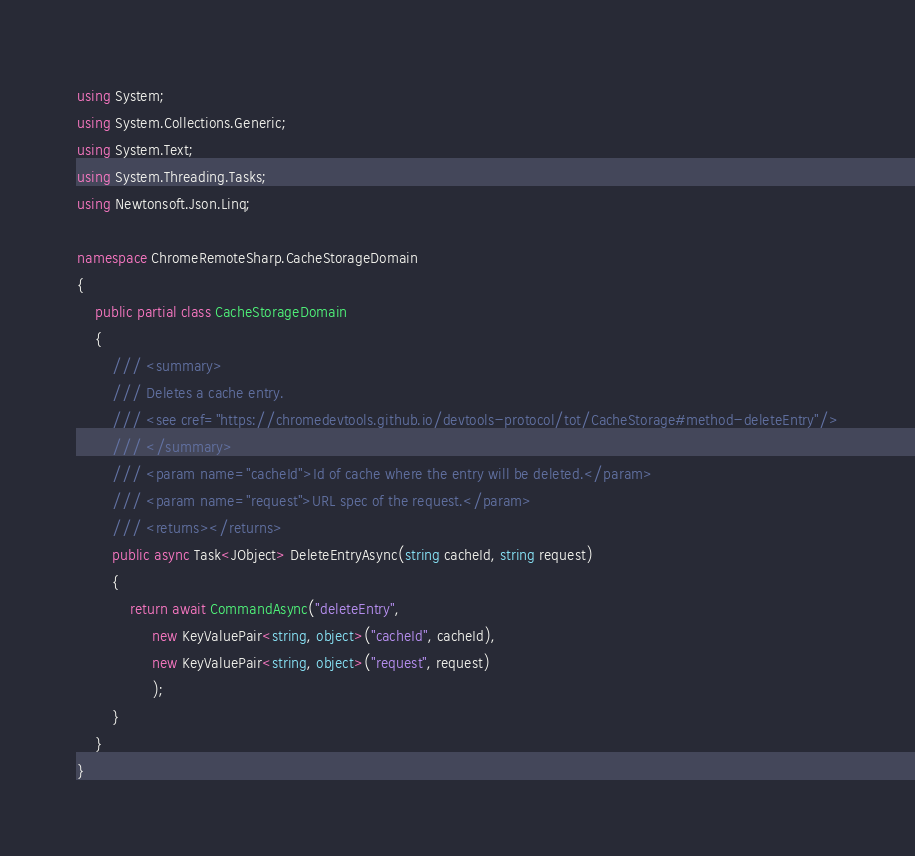<code> <loc_0><loc_0><loc_500><loc_500><_C#_>using System;
using System.Collections.Generic;
using System.Text;
using System.Threading.Tasks;
using Newtonsoft.Json.Linq;

namespace ChromeRemoteSharp.CacheStorageDomain
{
    public partial class CacheStorageDomain
    {
        /// <summary>
        /// Deletes a cache entry.
        /// <see cref="https://chromedevtools.github.io/devtools-protocol/tot/CacheStorage#method-deleteEntry"/>
        /// </summary>
        /// <param name="cacheId">Id of cache where the entry will be deleted.</param>
        /// <param name="request">URL spec of the request.</param>
        /// <returns></returns>
        public async Task<JObject> DeleteEntryAsync(string cacheId, string request)
        {
            return await CommandAsync("deleteEntry", 
                 new KeyValuePair<string, object>("cacheId", cacheId), 
                 new KeyValuePair<string, object>("request", request)
                 );
        }
    }
}
</code> 